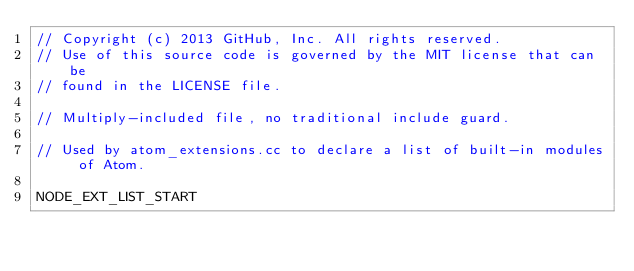Convert code to text. <code><loc_0><loc_0><loc_500><loc_500><_C_>// Copyright (c) 2013 GitHub, Inc. All rights reserved.
// Use of this source code is governed by the MIT license that can be
// found in the LICENSE file.

// Multiply-included file, no traditional include guard.

// Used by atom_extensions.cc to declare a list of built-in modules of Atom.

NODE_EXT_LIST_START
</code> 